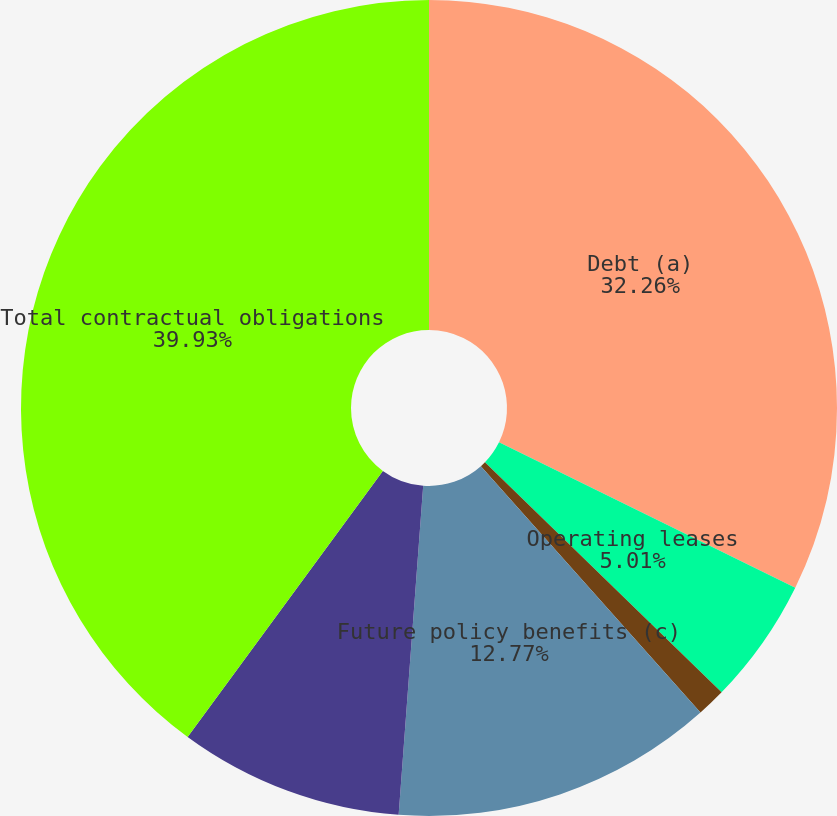Convert chart to OTSL. <chart><loc_0><loc_0><loc_500><loc_500><pie_chart><fcel>Debt (a)<fcel>Operating leases<fcel>Purchase and other obligations<fcel>Future policy benefits (c)<fcel>Other liabilities recorded on<fcel>Total contractual obligations<nl><fcel>32.26%<fcel>5.01%<fcel>1.14%<fcel>12.77%<fcel>8.89%<fcel>39.92%<nl></chart> 